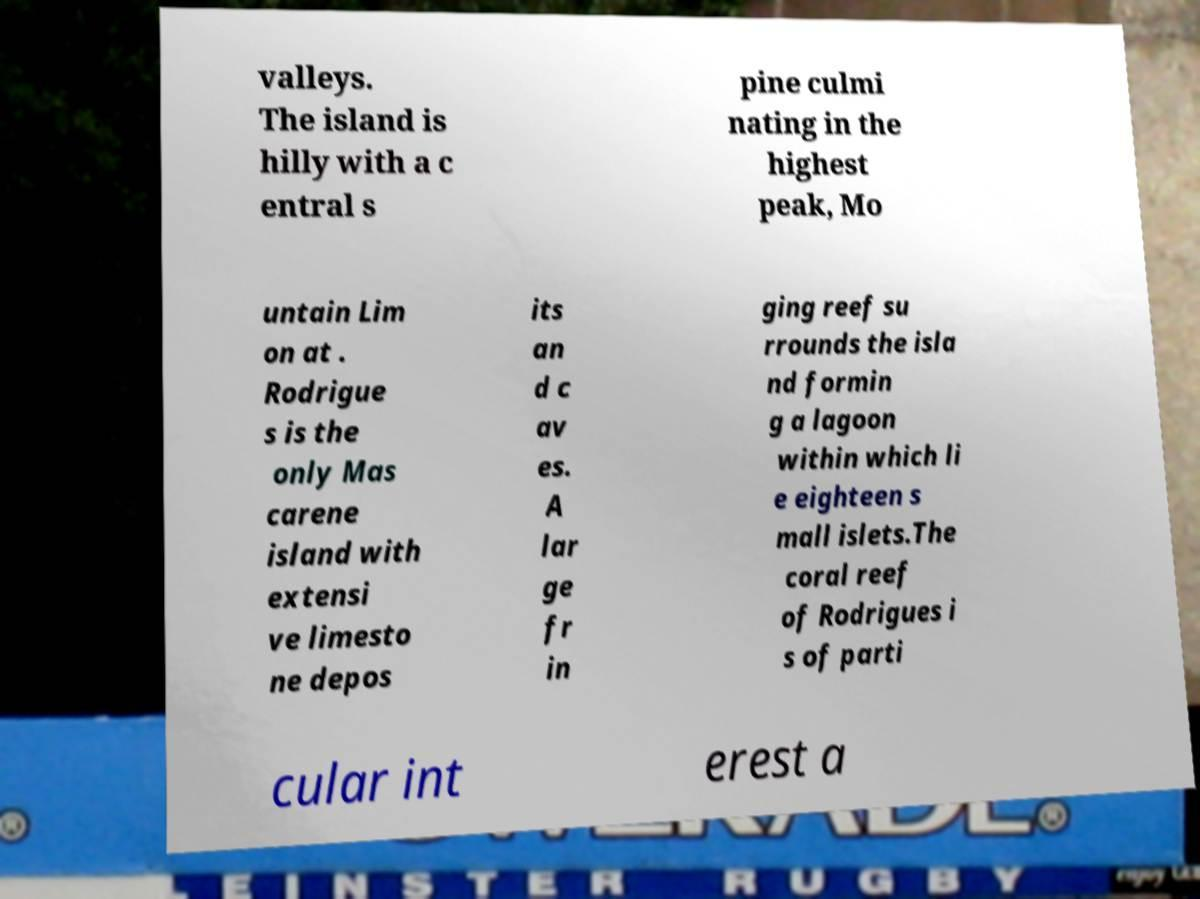Could you extract and type out the text from this image? valleys. The island is hilly with a c entral s pine culmi nating in the highest peak, Mo untain Lim on at . Rodrigue s is the only Mas carene island with extensi ve limesto ne depos its an d c av es. A lar ge fr in ging reef su rrounds the isla nd formin g a lagoon within which li e eighteen s mall islets.The coral reef of Rodrigues i s of parti cular int erest a 